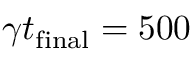Convert formula to latex. <formula><loc_0><loc_0><loc_500><loc_500>\gamma t _ { f i n a l } = 5 0 0</formula> 